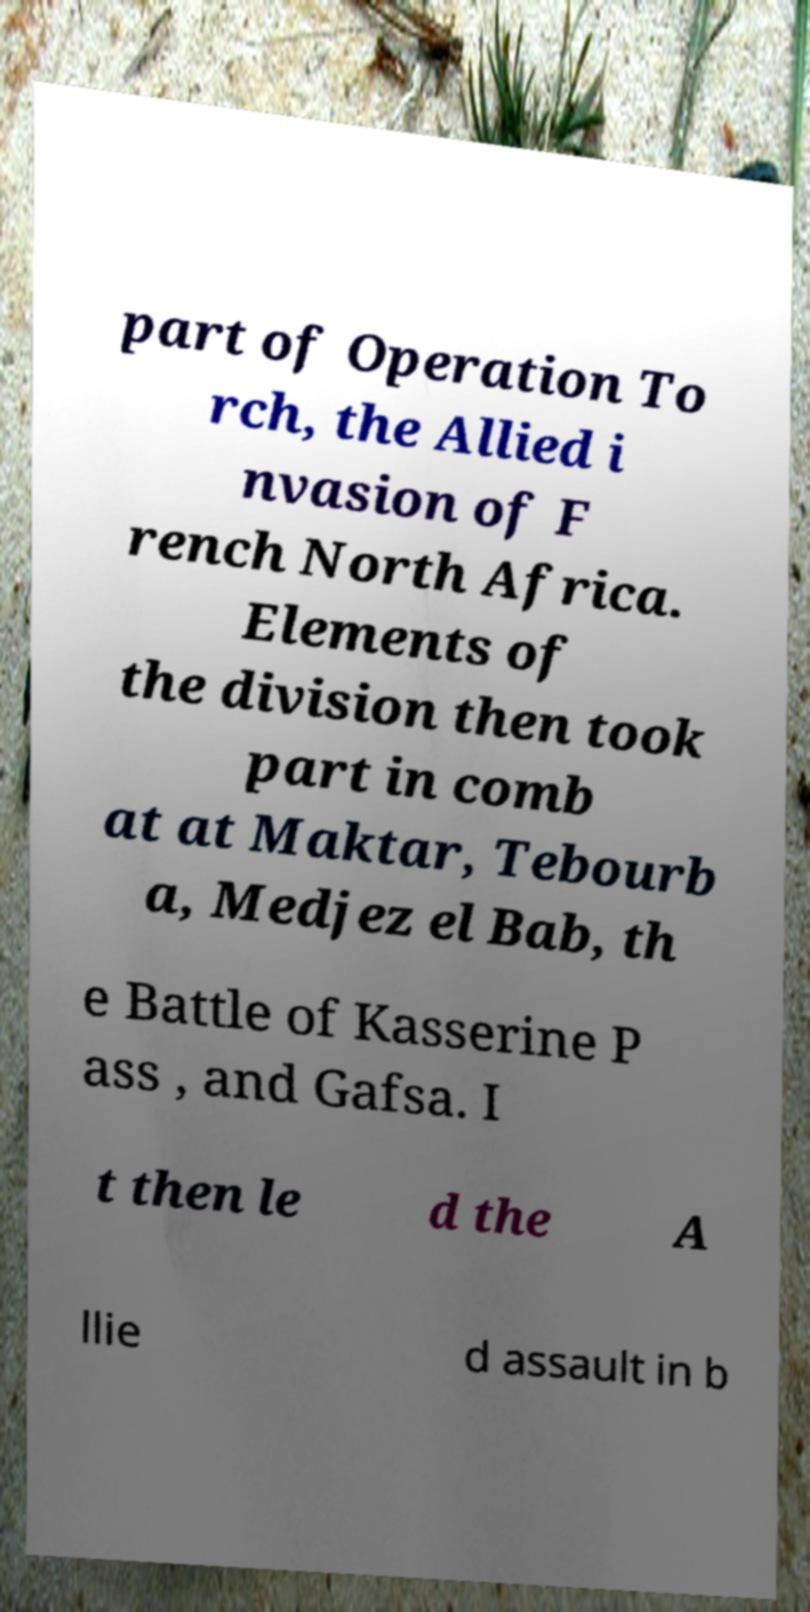Could you assist in decoding the text presented in this image and type it out clearly? part of Operation To rch, the Allied i nvasion of F rench North Africa. Elements of the division then took part in comb at at Maktar, Tebourb a, Medjez el Bab, th e Battle of Kasserine P ass , and Gafsa. I t then le d the A llie d assault in b 